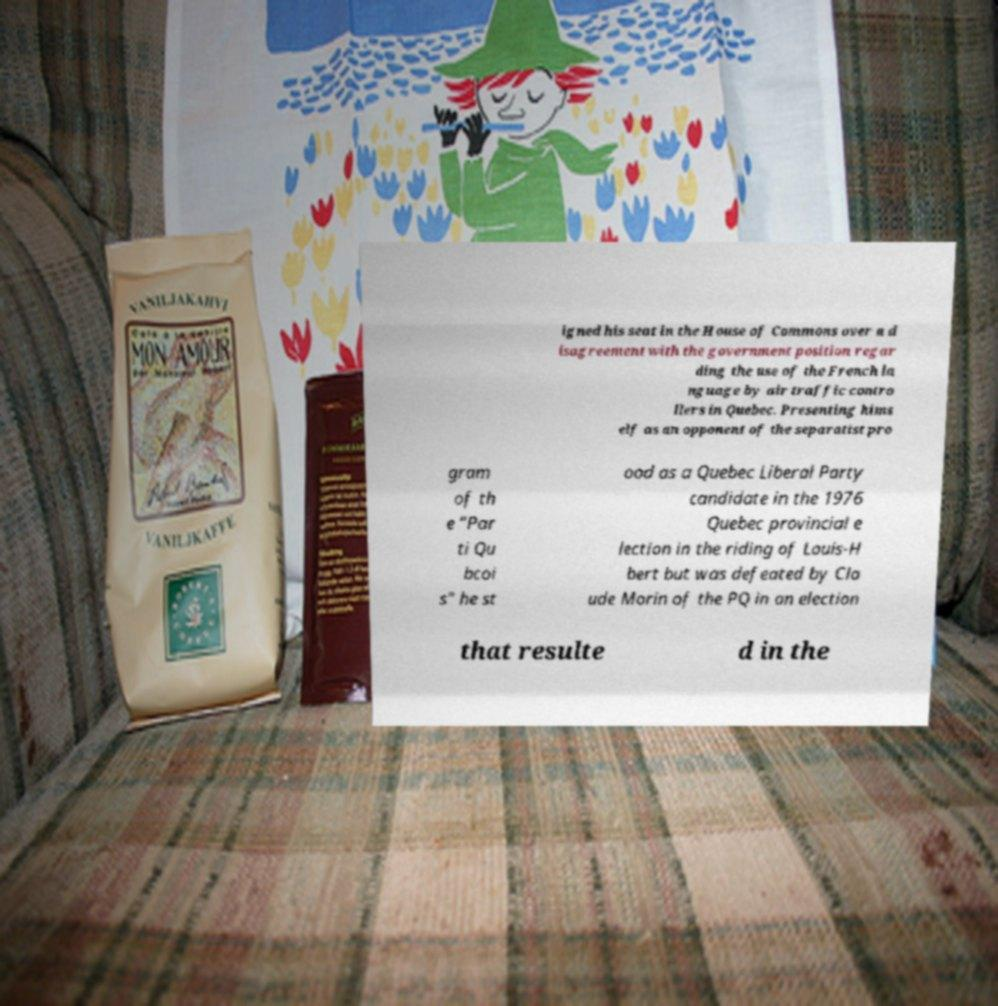What messages or text are displayed in this image? I need them in a readable, typed format. igned his seat in the House of Commons over a d isagreement with the government position regar ding the use of the French la nguage by air traffic contro llers in Quebec. Presenting hims elf as an opponent of the separatist pro gram of th e "Par ti Qu bcoi s" he st ood as a Quebec Liberal Party candidate in the 1976 Quebec provincial e lection in the riding of Louis-H bert but was defeated by Cla ude Morin of the PQ in an election that resulte d in the 